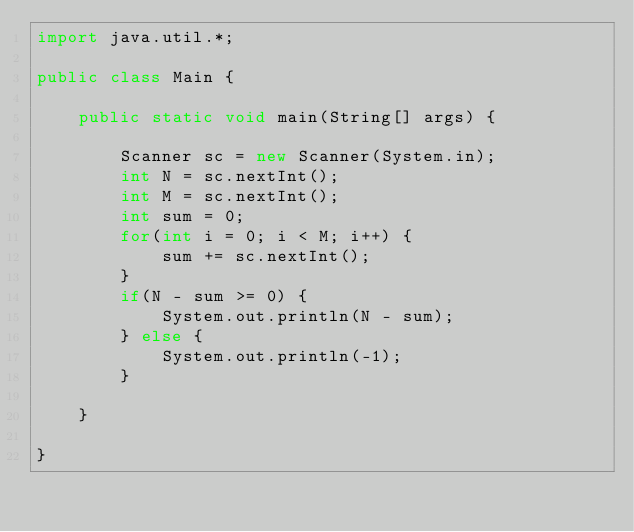Convert code to text. <code><loc_0><loc_0><loc_500><loc_500><_Java_>import java.util.*;

public class Main {

	public static void main(String[] args) {
	
		Scanner sc = new Scanner(System.in);
		int N = sc.nextInt();
		int M = sc.nextInt();
		int sum = 0;
		for(int i = 0; i < M; i++) {
			sum += sc.nextInt();
		}
		if(N - sum >= 0) {
			System.out.println(N - sum);
		} else {
			System.out.println(-1);
		}

	}
	
}</code> 